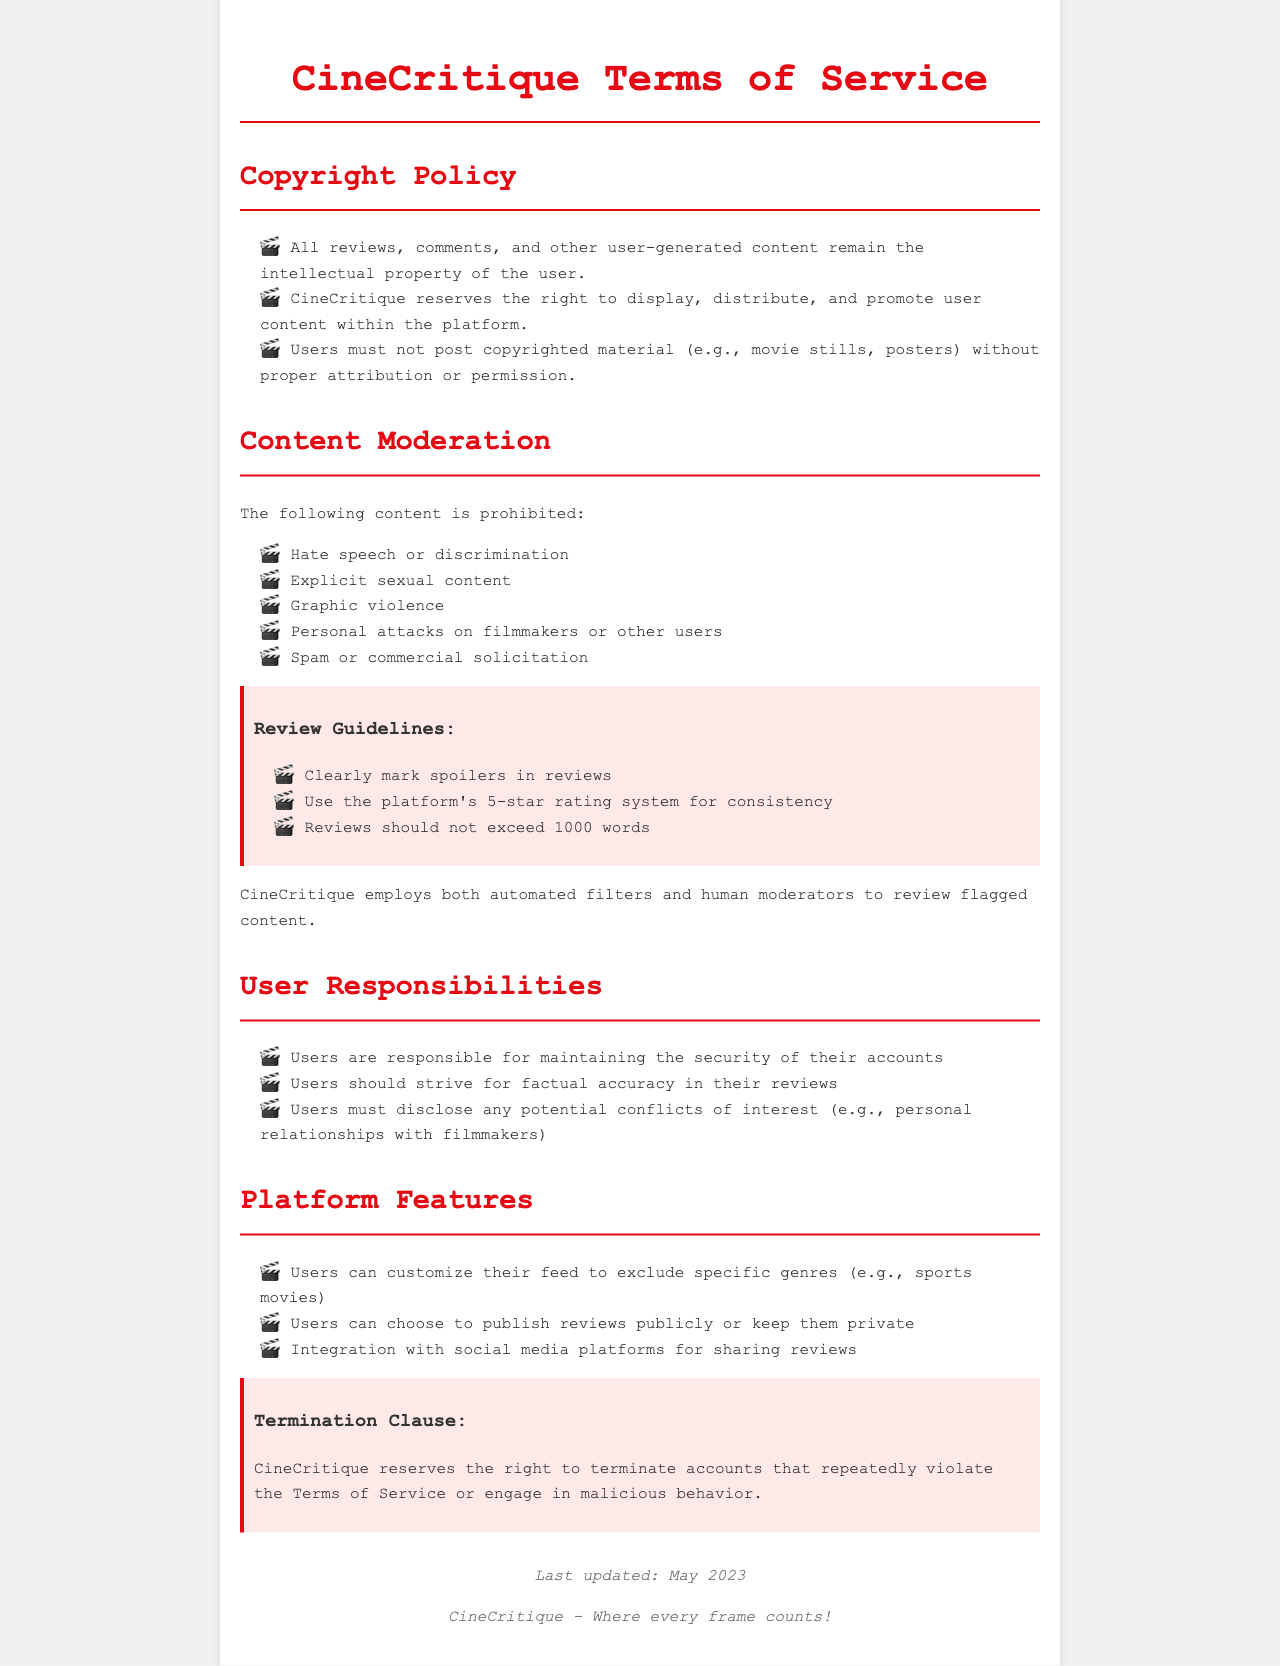What rights do users have over their reviews? Users retain intellectual property rights over their reviews, comments, and other user-generated content.
Answer: Intellectual property What must users do to post copyrighted materials? Users must obtain proper attribution or permission before posting copyrighted materials like movie stills or posters.
Answer: Obtain permission What type of content is prohibited on the platform? The document lists several types of prohibited content, including hate speech, explicit sexual content, and spam.
Answer: Hate speech What are users responsible for in relation to their accounts? Users are responsible for maintaining the security of their accounts.
Answer: Security What should users do if their review contains spoilers? Users should clearly mark spoilers in their reviews.
Answer: Mark spoilers How many words can reviews not exceed? The document specifies that reviews should not exceed a certain word limit.
Answer: 1000 words What system should users use for consistency in reviews? The platform's rating system is recommended for consistency.
Answer: 5-star rating system What action can CineCritique take against accounts that violate the Terms of Service? CineCritique reserves the right to terminate accounts for repeated violations.
Answer: Termination What does CineCritique integrate with for sharing reviews? The platform allows integration with social media platforms.
Answer: Social media platforms 